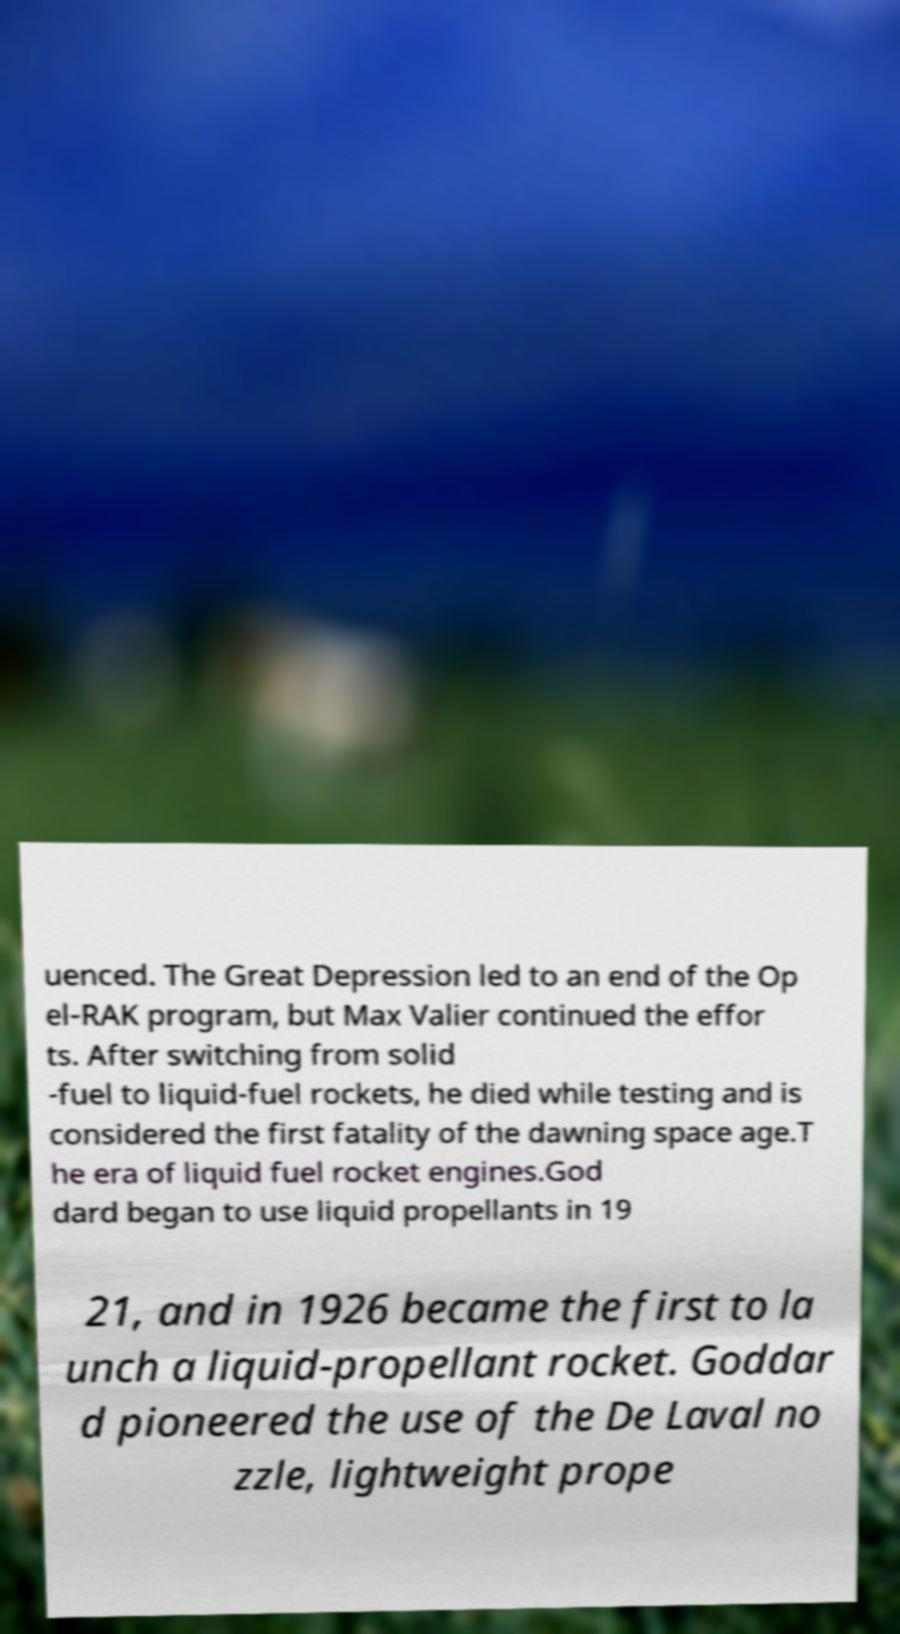Please identify and transcribe the text found in this image. uenced. The Great Depression led to an end of the Op el-RAK program, but Max Valier continued the effor ts. After switching from solid -fuel to liquid-fuel rockets, he died while testing and is considered the first fatality of the dawning space age.T he era of liquid fuel rocket engines.God dard began to use liquid propellants in 19 21, and in 1926 became the first to la unch a liquid-propellant rocket. Goddar d pioneered the use of the De Laval no zzle, lightweight prope 